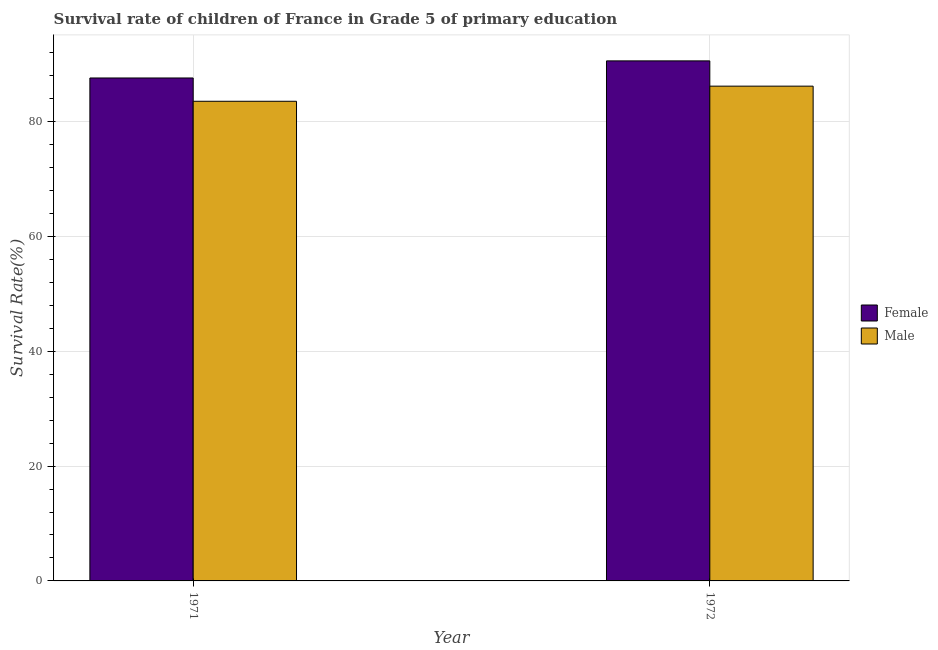How many different coloured bars are there?
Offer a very short reply. 2. How many bars are there on the 1st tick from the left?
Your answer should be compact. 2. How many bars are there on the 2nd tick from the right?
Offer a very short reply. 2. In how many cases, is the number of bars for a given year not equal to the number of legend labels?
Provide a succinct answer. 0. What is the survival rate of female students in primary education in 1971?
Your response must be concise. 87.58. Across all years, what is the maximum survival rate of female students in primary education?
Provide a succinct answer. 90.56. Across all years, what is the minimum survival rate of male students in primary education?
Keep it short and to the point. 83.52. In which year was the survival rate of female students in primary education maximum?
Keep it short and to the point. 1972. What is the total survival rate of female students in primary education in the graph?
Ensure brevity in your answer.  178.14. What is the difference between the survival rate of female students in primary education in 1971 and that in 1972?
Offer a terse response. -2.98. What is the difference between the survival rate of female students in primary education in 1971 and the survival rate of male students in primary education in 1972?
Provide a succinct answer. -2.98. What is the average survival rate of female students in primary education per year?
Provide a succinct answer. 89.07. In the year 1972, what is the difference between the survival rate of female students in primary education and survival rate of male students in primary education?
Your answer should be compact. 0. What is the ratio of the survival rate of female students in primary education in 1971 to that in 1972?
Keep it short and to the point. 0.97. Is the survival rate of female students in primary education in 1971 less than that in 1972?
Make the answer very short. Yes. In how many years, is the survival rate of male students in primary education greater than the average survival rate of male students in primary education taken over all years?
Give a very brief answer. 1. What does the 2nd bar from the left in 1972 represents?
Provide a succinct answer. Male. What does the 2nd bar from the right in 1971 represents?
Provide a succinct answer. Female. How many bars are there?
Your answer should be compact. 4. Are all the bars in the graph horizontal?
Your answer should be compact. No. How many years are there in the graph?
Offer a terse response. 2. What is the difference between two consecutive major ticks on the Y-axis?
Give a very brief answer. 20. Does the graph contain any zero values?
Your answer should be very brief. No. How are the legend labels stacked?
Your answer should be very brief. Vertical. What is the title of the graph?
Offer a very short reply. Survival rate of children of France in Grade 5 of primary education. Does "Female labor force" appear as one of the legend labels in the graph?
Provide a short and direct response. No. What is the label or title of the Y-axis?
Provide a short and direct response. Survival Rate(%). What is the Survival Rate(%) of Female in 1971?
Ensure brevity in your answer.  87.58. What is the Survival Rate(%) in Male in 1971?
Ensure brevity in your answer.  83.52. What is the Survival Rate(%) of Female in 1972?
Your answer should be compact. 90.56. What is the Survival Rate(%) of Male in 1972?
Give a very brief answer. 86.16. Across all years, what is the maximum Survival Rate(%) in Female?
Provide a succinct answer. 90.56. Across all years, what is the maximum Survival Rate(%) in Male?
Keep it short and to the point. 86.16. Across all years, what is the minimum Survival Rate(%) in Female?
Provide a short and direct response. 87.58. Across all years, what is the minimum Survival Rate(%) in Male?
Offer a terse response. 83.52. What is the total Survival Rate(%) in Female in the graph?
Your answer should be very brief. 178.14. What is the total Survival Rate(%) of Male in the graph?
Your answer should be compact. 169.68. What is the difference between the Survival Rate(%) in Female in 1971 and that in 1972?
Provide a short and direct response. -2.98. What is the difference between the Survival Rate(%) of Male in 1971 and that in 1972?
Provide a short and direct response. -2.63. What is the difference between the Survival Rate(%) in Female in 1971 and the Survival Rate(%) in Male in 1972?
Provide a succinct answer. 1.42. What is the average Survival Rate(%) in Female per year?
Give a very brief answer. 89.07. What is the average Survival Rate(%) of Male per year?
Provide a succinct answer. 84.84. In the year 1971, what is the difference between the Survival Rate(%) of Female and Survival Rate(%) of Male?
Your answer should be very brief. 4.06. In the year 1972, what is the difference between the Survival Rate(%) of Female and Survival Rate(%) of Male?
Ensure brevity in your answer.  4.4. What is the ratio of the Survival Rate(%) in Female in 1971 to that in 1972?
Offer a very short reply. 0.97. What is the ratio of the Survival Rate(%) in Male in 1971 to that in 1972?
Offer a very short reply. 0.97. What is the difference between the highest and the second highest Survival Rate(%) in Female?
Give a very brief answer. 2.98. What is the difference between the highest and the second highest Survival Rate(%) of Male?
Offer a very short reply. 2.63. What is the difference between the highest and the lowest Survival Rate(%) of Female?
Your response must be concise. 2.98. What is the difference between the highest and the lowest Survival Rate(%) of Male?
Make the answer very short. 2.63. 